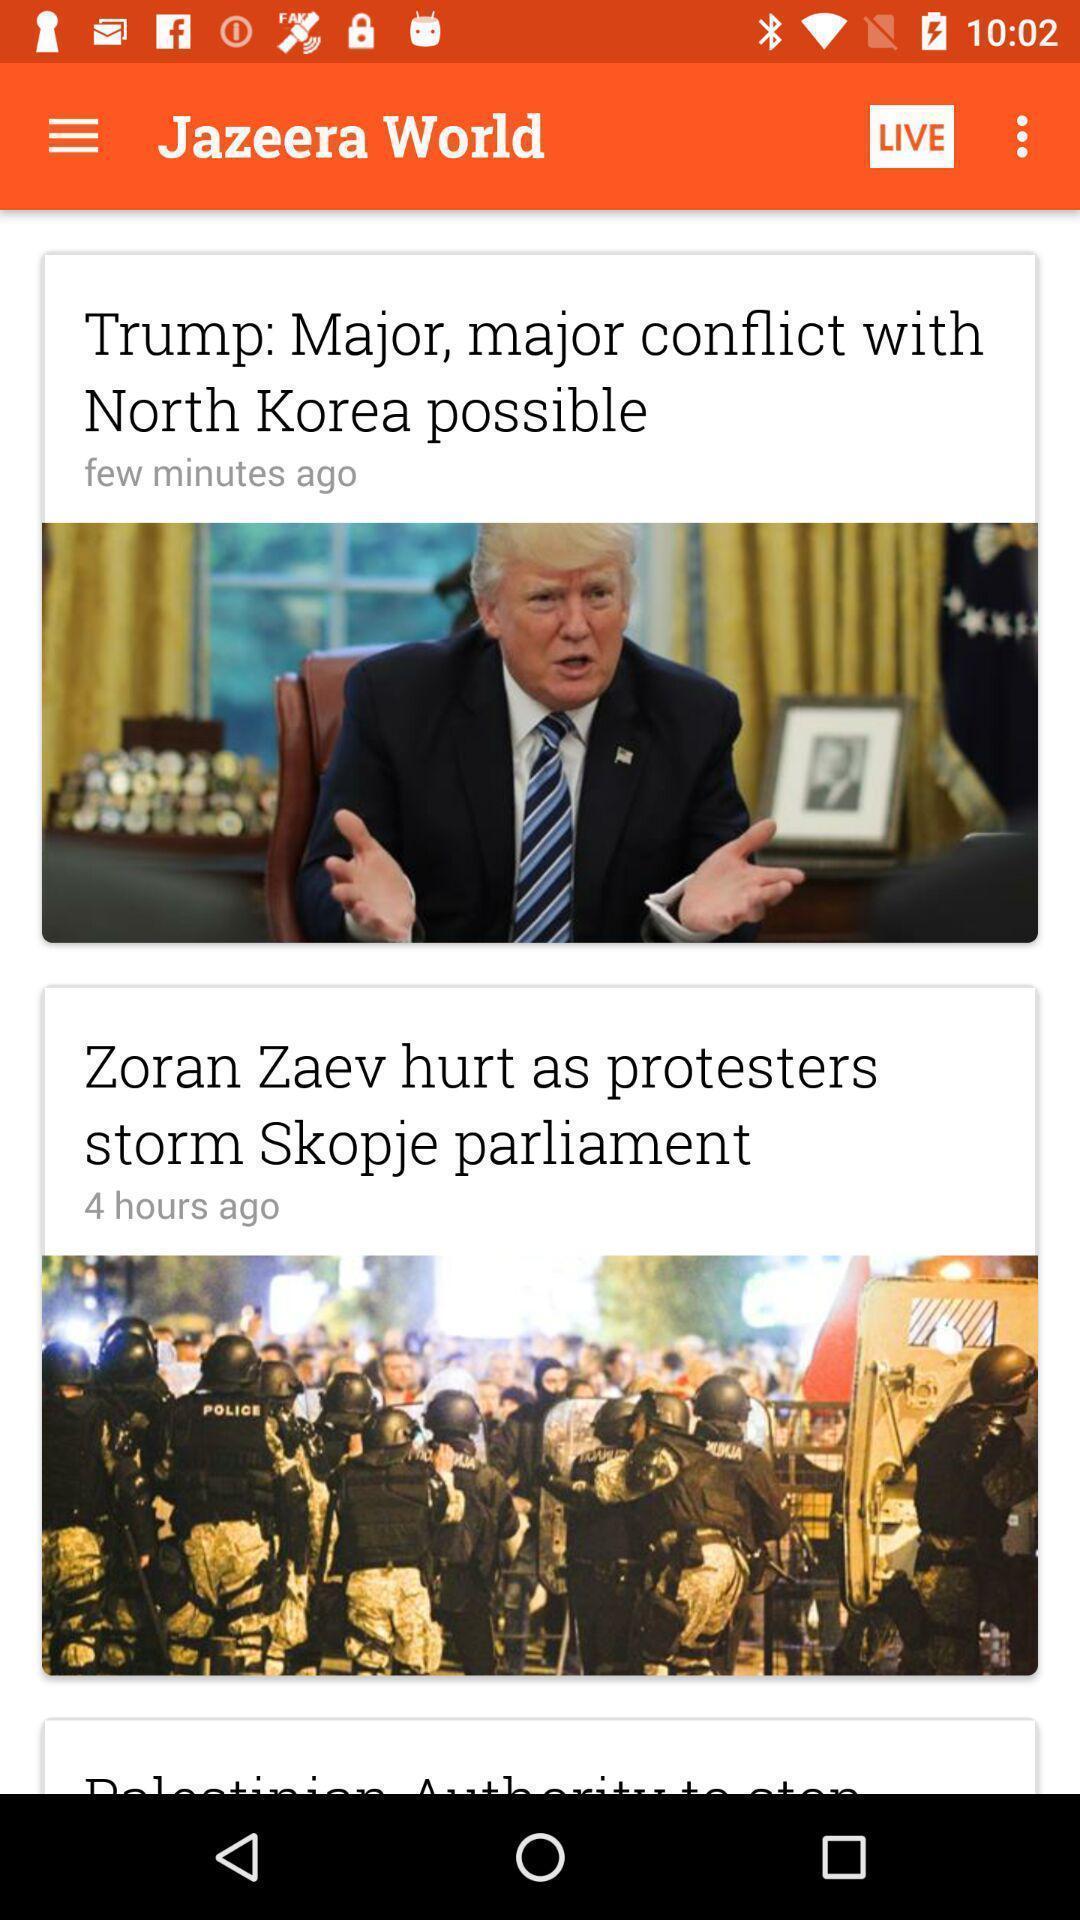Describe this image in words. Window displaying live news articles. 